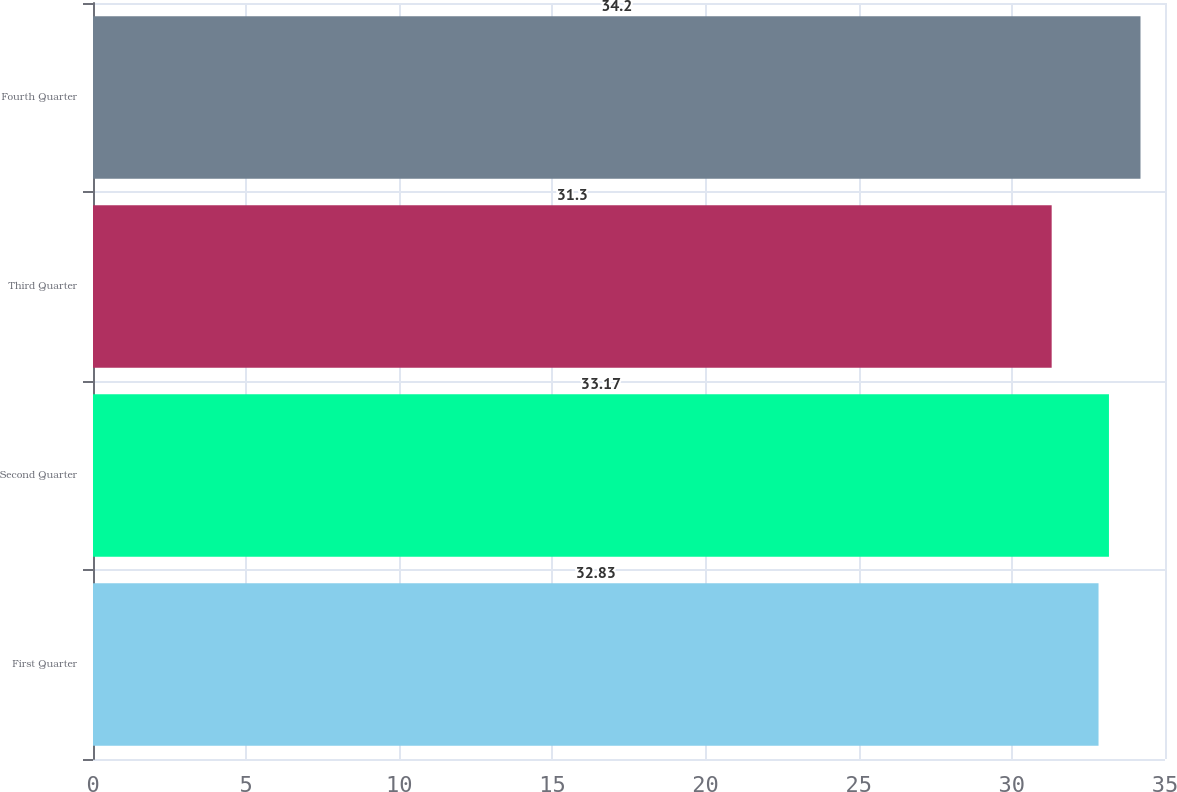Convert chart to OTSL. <chart><loc_0><loc_0><loc_500><loc_500><bar_chart><fcel>First Quarter<fcel>Second Quarter<fcel>Third Quarter<fcel>Fourth Quarter<nl><fcel>32.83<fcel>33.17<fcel>31.3<fcel>34.2<nl></chart> 